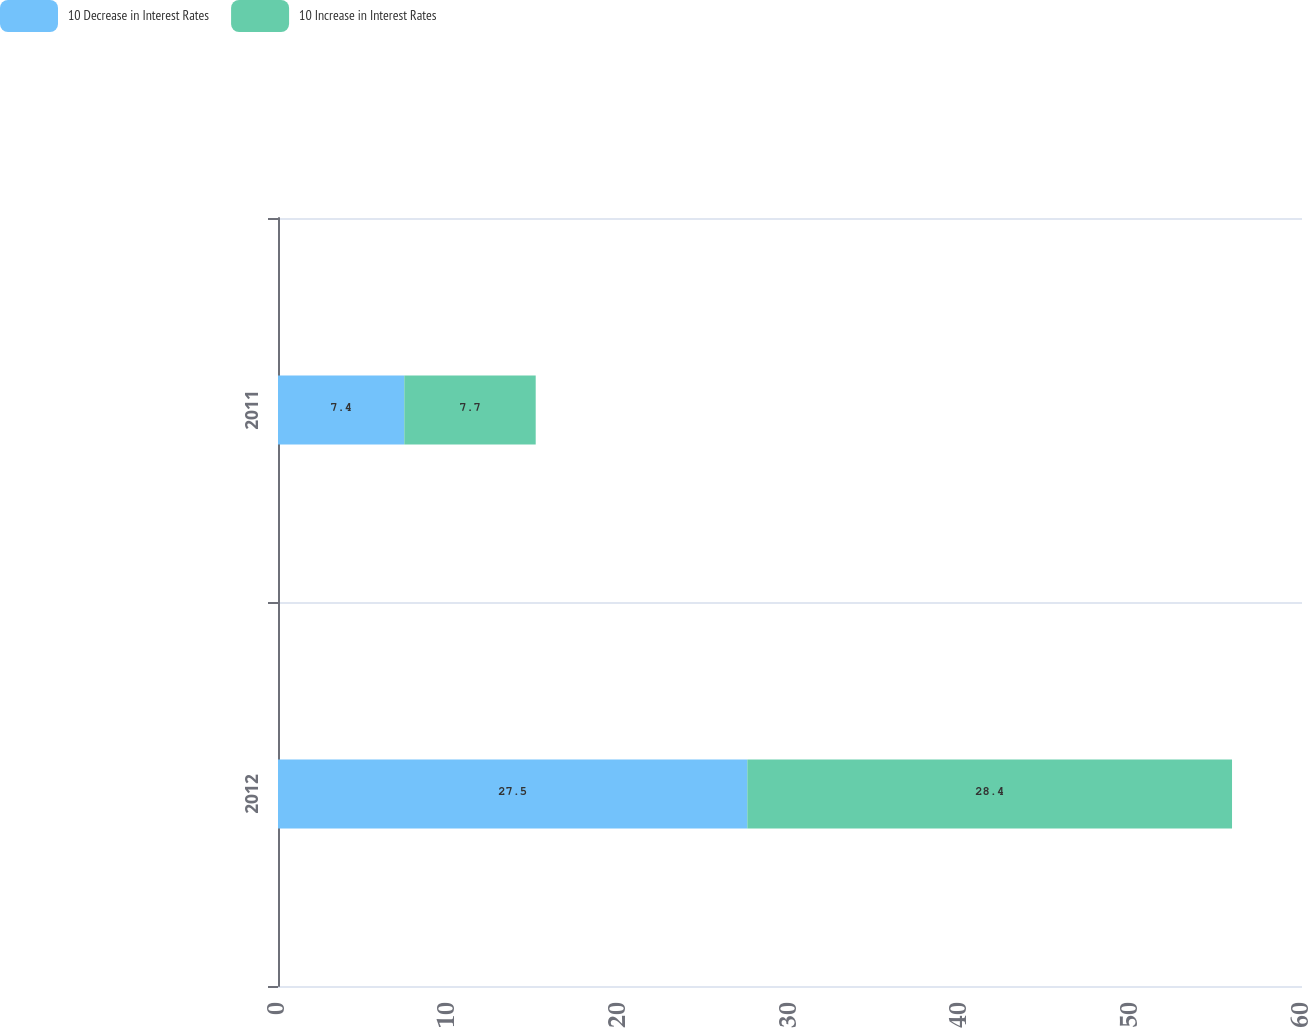Convert chart. <chart><loc_0><loc_0><loc_500><loc_500><stacked_bar_chart><ecel><fcel>2012<fcel>2011<nl><fcel>10 Decrease in Interest Rates<fcel>27.5<fcel>7.4<nl><fcel>10 Increase in Interest Rates<fcel>28.4<fcel>7.7<nl></chart> 